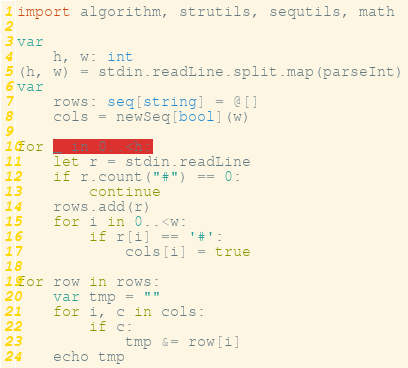<code> <loc_0><loc_0><loc_500><loc_500><_Nim_>import algorithm, strutils, sequtils, math

var
    h, w: int
(h, w) = stdin.readLine.split.map(parseInt)
var
    rows: seq[string] = @[]
    cols = newSeq[bool](w)

for _ in 0..<h:
    let r = stdin.readLine
    if r.count("#") == 0:
        continue
    rows.add(r)
    for i in 0..<w:
        if r[i] == '#':
            cols[i] = true

for row in rows:
    var tmp = ""
    for i, c in cols:
        if c:
            tmp &= row[i]
    echo tmp
</code> 